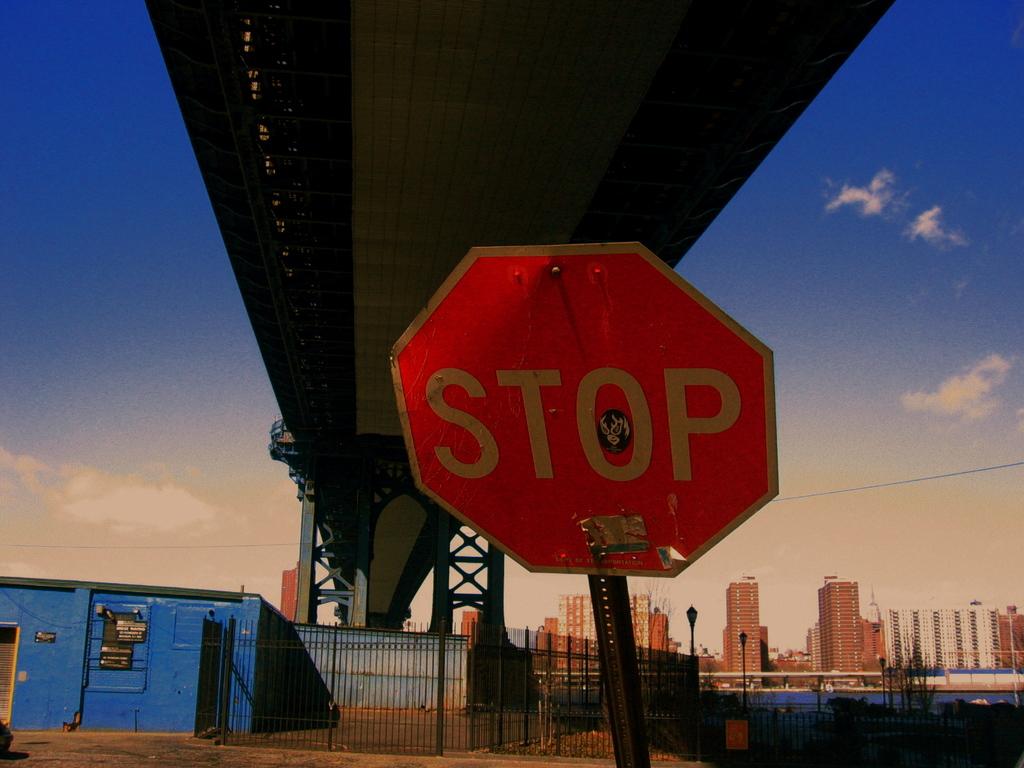What does the sign say?
Your answer should be compact. Stop. 